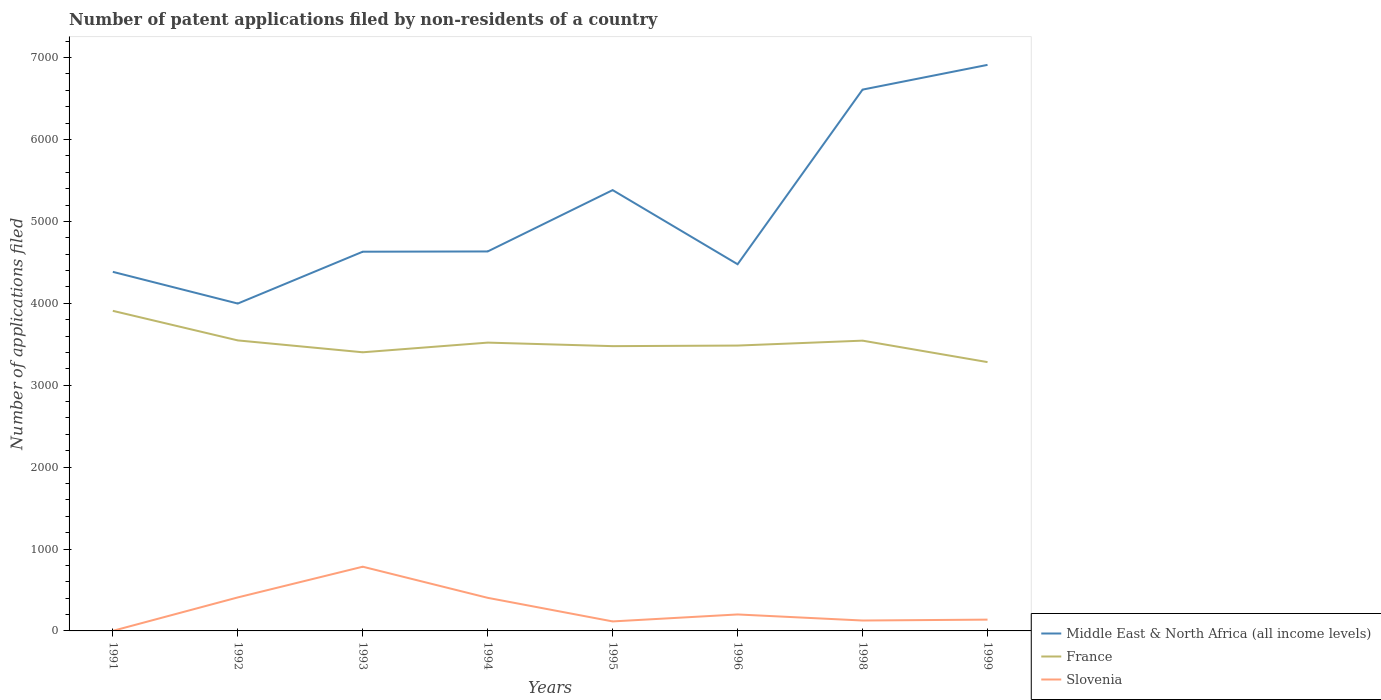Does the line corresponding to Middle East & North Africa (all income levels) intersect with the line corresponding to France?
Give a very brief answer. No. Is the number of lines equal to the number of legend labels?
Give a very brief answer. Yes. Across all years, what is the maximum number of applications filed in Slovenia?
Provide a succinct answer. 1. In which year was the number of applications filed in Slovenia maximum?
Offer a very short reply. 1991. What is the total number of applications filed in Slovenia in the graph?
Offer a terse response. -115. What is the difference between the highest and the second highest number of applications filed in France?
Your answer should be compact. 626. What is the difference between the highest and the lowest number of applications filed in Middle East & North Africa (all income levels)?
Give a very brief answer. 3. What is the difference between two consecutive major ticks on the Y-axis?
Your answer should be compact. 1000. Are the values on the major ticks of Y-axis written in scientific E-notation?
Your response must be concise. No. Does the graph contain any zero values?
Provide a short and direct response. No. Does the graph contain grids?
Provide a short and direct response. No. Where does the legend appear in the graph?
Give a very brief answer. Bottom right. How are the legend labels stacked?
Offer a terse response. Vertical. What is the title of the graph?
Provide a short and direct response. Number of patent applications filed by non-residents of a country. Does "Hungary" appear as one of the legend labels in the graph?
Your answer should be very brief. No. What is the label or title of the X-axis?
Offer a very short reply. Years. What is the label or title of the Y-axis?
Provide a short and direct response. Number of applications filed. What is the Number of applications filed of Middle East & North Africa (all income levels) in 1991?
Offer a very short reply. 4384. What is the Number of applications filed of France in 1991?
Your answer should be very brief. 3908. What is the Number of applications filed in Slovenia in 1991?
Give a very brief answer. 1. What is the Number of applications filed of Middle East & North Africa (all income levels) in 1992?
Offer a very short reply. 3997. What is the Number of applications filed of France in 1992?
Offer a very short reply. 3547. What is the Number of applications filed of Slovenia in 1992?
Ensure brevity in your answer.  409. What is the Number of applications filed in Middle East & North Africa (all income levels) in 1993?
Make the answer very short. 4630. What is the Number of applications filed of France in 1993?
Provide a succinct answer. 3402. What is the Number of applications filed of Slovenia in 1993?
Make the answer very short. 784. What is the Number of applications filed in Middle East & North Africa (all income levels) in 1994?
Provide a succinct answer. 4633. What is the Number of applications filed of France in 1994?
Your answer should be very brief. 3520. What is the Number of applications filed of Slovenia in 1994?
Make the answer very short. 404. What is the Number of applications filed in Middle East & North Africa (all income levels) in 1995?
Your response must be concise. 5382. What is the Number of applications filed in France in 1995?
Keep it short and to the point. 3477. What is the Number of applications filed of Slovenia in 1995?
Your answer should be compact. 116. What is the Number of applications filed in Middle East & North Africa (all income levels) in 1996?
Give a very brief answer. 4477. What is the Number of applications filed in France in 1996?
Your response must be concise. 3484. What is the Number of applications filed of Slovenia in 1996?
Make the answer very short. 201. What is the Number of applications filed of Middle East & North Africa (all income levels) in 1998?
Your answer should be compact. 6609. What is the Number of applications filed of France in 1998?
Give a very brief answer. 3544. What is the Number of applications filed of Slovenia in 1998?
Your answer should be very brief. 127. What is the Number of applications filed in Middle East & North Africa (all income levels) in 1999?
Your answer should be compact. 6911. What is the Number of applications filed in France in 1999?
Ensure brevity in your answer.  3282. What is the Number of applications filed of Slovenia in 1999?
Make the answer very short. 138. Across all years, what is the maximum Number of applications filed in Middle East & North Africa (all income levels)?
Provide a succinct answer. 6911. Across all years, what is the maximum Number of applications filed in France?
Your answer should be compact. 3908. Across all years, what is the maximum Number of applications filed of Slovenia?
Give a very brief answer. 784. Across all years, what is the minimum Number of applications filed in Middle East & North Africa (all income levels)?
Your answer should be compact. 3997. Across all years, what is the minimum Number of applications filed of France?
Offer a terse response. 3282. What is the total Number of applications filed in Middle East & North Africa (all income levels) in the graph?
Your response must be concise. 4.10e+04. What is the total Number of applications filed in France in the graph?
Give a very brief answer. 2.82e+04. What is the total Number of applications filed of Slovenia in the graph?
Provide a short and direct response. 2180. What is the difference between the Number of applications filed of Middle East & North Africa (all income levels) in 1991 and that in 1992?
Provide a succinct answer. 387. What is the difference between the Number of applications filed of France in 1991 and that in 1992?
Your answer should be very brief. 361. What is the difference between the Number of applications filed of Slovenia in 1991 and that in 1992?
Make the answer very short. -408. What is the difference between the Number of applications filed in Middle East & North Africa (all income levels) in 1991 and that in 1993?
Make the answer very short. -246. What is the difference between the Number of applications filed in France in 1991 and that in 1993?
Your response must be concise. 506. What is the difference between the Number of applications filed of Slovenia in 1991 and that in 1993?
Offer a very short reply. -783. What is the difference between the Number of applications filed in Middle East & North Africa (all income levels) in 1991 and that in 1994?
Give a very brief answer. -249. What is the difference between the Number of applications filed in France in 1991 and that in 1994?
Ensure brevity in your answer.  388. What is the difference between the Number of applications filed in Slovenia in 1991 and that in 1994?
Provide a succinct answer. -403. What is the difference between the Number of applications filed in Middle East & North Africa (all income levels) in 1991 and that in 1995?
Provide a succinct answer. -998. What is the difference between the Number of applications filed in France in 1991 and that in 1995?
Your answer should be compact. 431. What is the difference between the Number of applications filed in Slovenia in 1991 and that in 1995?
Offer a terse response. -115. What is the difference between the Number of applications filed of Middle East & North Africa (all income levels) in 1991 and that in 1996?
Your response must be concise. -93. What is the difference between the Number of applications filed of France in 1991 and that in 1996?
Your response must be concise. 424. What is the difference between the Number of applications filed in Slovenia in 1991 and that in 1996?
Keep it short and to the point. -200. What is the difference between the Number of applications filed of Middle East & North Africa (all income levels) in 1991 and that in 1998?
Your answer should be very brief. -2225. What is the difference between the Number of applications filed in France in 1991 and that in 1998?
Make the answer very short. 364. What is the difference between the Number of applications filed in Slovenia in 1991 and that in 1998?
Offer a terse response. -126. What is the difference between the Number of applications filed in Middle East & North Africa (all income levels) in 1991 and that in 1999?
Your answer should be very brief. -2527. What is the difference between the Number of applications filed in France in 1991 and that in 1999?
Make the answer very short. 626. What is the difference between the Number of applications filed in Slovenia in 1991 and that in 1999?
Make the answer very short. -137. What is the difference between the Number of applications filed in Middle East & North Africa (all income levels) in 1992 and that in 1993?
Provide a short and direct response. -633. What is the difference between the Number of applications filed in France in 1992 and that in 1993?
Your answer should be very brief. 145. What is the difference between the Number of applications filed in Slovenia in 1992 and that in 1993?
Offer a terse response. -375. What is the difference between the Number of applications filed in Middle East & North Africa (all income levels) in 1992 and that in 1994?
Make the answer very short. -636. What is the difference between the Number of applications filed in Middle East & North Africa (all income levels) in 1992 and that in 1995?
Keep it short and to the point. -1385. What is the difference between the Number of applications filed of Slovenia in 1992 and that in 1995?
Make the answer very short. 293. What is the difference between the Number of applications filed in Middle East & North Africa (all income levels) in 1992 and that in 1996?
Make the answer very short. -480. What is the difference between the Number of applications filed of Slovenia in 1992 and that in 1996?
Offer a terse response. 208. What is the difference between the Number of applications filed of Middle East & North Africa (all income levels) in 1992 and that in 1998?
Give a very brief answer. -2612. What is the difference between the Number of applications filed of Slovenia in 1992 and that in 1998?
Ensure brevity in your answer.  282. What is the difference between the Number of applications filed in Middle East & North Africa (all income levels) in 1992 and that in 1999?
Your response must be concise. -2914. What is the difference between the Number of applications filed of France in 1992 and that in 1999?
Give a very brief answer. 265. What is the difference between the Number of applications filed of Slovenia in 1992 and that in 1999?
Your response must be concise. 271. What is the difference between the Number of applications filed in Middle East & North Africa (all income levels) in 1993 and that in 1994?
Offer a very short reply. -3. What is the difference between the Number of applications filed in France in 1993 and that in 1994?
Provide a short and direct response. -118. What is the difference between the Number of applications filed of Slovenia in 1993 and that in 1994?
Ensure brevity in your answer.  380. What is the difference between the Number of applications filed in Middle East & North Africa (all income levels) in 1993 and that in 1995?
Keep it short and to the point. -752. What is the difference between the Number of applications filed in France in 1993 and that in 1995?
Provide a succinct answer. -75. What is the difference between the Number of applications filed of Slovenia in 1993 and that in 1995?
Your answer should be compact. 668. What is the difference between the Number of applications filed of Middle East & North Africa (all income levels) in 1993 and that in 1996?
Give a very brief answer. 153. What is the difference between the Number of applications filed in France in 1993 and that in 1996?
Provide a succinct answer. -82. What is the difference between the Number of applications filed of Slovenia in 1993 and that in 1996?
Your response must be concise. 583. What is the difference between the Number of applications filed of Middle East & North Africa (all income levels) in 1993 and that in 1998?
Ensure brevity in your answer.  -1979. What is the difference between the Number of applications filed in France in 1993 and that in 1998?
Your answer should be very brief. -142. What is the difference between the Number of applications filed of Slovenia in 1993 and that in 1998?
Give a very brief answer. 657. What is the difference between the Number of applications filed in Middle East & North Africa (all income levels) in 1993 and that in 1999?
Provide a short and direct response. -2281. What is the difference between the Number of applications filed of France in 1993 and that in 1999?
Provide a succinct answer. 120. What is the difference between the Number of applications filed in Slovenia in 1993 and that in 1999?
Keep it short and to the point. 646. What is the difference between the Number of applications filed of Middle East & North Africa (all income levels) in 1994 and that in 1995?
Ensure brevity in your answer.  -749. What is the difference between the Number of applications filed of France in 1994 and that in 1995?
Make the answer very short. 43. What is the difference between the Number of applications filed of Slovenia in 1994 and that in 1995?
Provide a short and direct response. 288. What is the difference between the Number of applications filed of Middle East & North Africa (all income levels) in 1994 and that in 1996?
Offer a very short reply. 156. What is the difference between the Number of applications filed in Slovenia in 1994 and that in 1996?
Your answer should be very brief. 203. What is the difference between the Number of applications filed in Middle East & North Africa (all income levels) in 1994 and that in 1998?
Offer a terse response. -1976. What is the difference between the Number of applications filed in France in 1994 and that in 1998?
Ensure brevity in your answer.  -24. What is the difference between the Number of applications filed of Slovenia in 1994 and that in 1998?
Your answer should be very brief. 277. What is the difference between the Number of applications filed of Middle East & North Africa (all income levels) in 1994 and that in 1999?
Provide a succinct answer. -2278. What is the difference between the Number of applications filed in France in 1994 and that in 1999?
Make the answer very short. 238. What is the difference between the Number of applications filed in Slovenia in 1994 and that in 1999?
Provide a succinct answer. 266. What is the difference between the Number of applications filed of Middle East & North Africa (all income levels) in 1995 and that in 1996?
Offer a terse response. 905. What is the difference between the Number of applications filed in France in 1995 and that in 1996?
Your response must be concise. -7. What is the difference between the Number of applications filed of Slovenia in 1995 and that in 1996?
Provide a short and direct response. -85. What is the difference between the Number of applications filed in Middle East & North Africa (all income levels) in 1995 and that in 1998?
Offer a terse response. -1227. What is the difference between the Number of applications filed of France in 1995 and that in 1998?
Make the answer very short. -67. What is the difference between the Number of applications filed of Middle East & North Africa (all income levels) in 1995 and that in 1999?
Your response must be concise. -1529. What is the difference between the Number of applications filed in France in 1995 and that in 1999?
Your answer should be compact. 195. What is the difference between the Number of applications filed of Middle East & North Africa (all income levels) in 1996 and that in 1998?
Ensure brevity in your answer.  -2132. What is the difference between the Number of applications filed in France in 1996 and that in 1998?
Provide a short and direct response. -60. What is the difference between the Number of applications filed in Middle East & North Africa (all income levels) in 1996 and that in 1999?
Make the answer very short. -2434. What is the difference between the Number of applications filed of France in 1996 and that in 1999?
Your response must be concise. 202. What is the difference between the Number of applications filed in Middle East & North Africa (all income levels) in 1998 and that in 1999?
Offer a very short reply. -302. What is the difference between the Number of applications filed in France in 1998 and that in 1999?
Make the answer very short. 262. What is the difference between the Number of applications filed in Middle East & North Africa (all income levels) in 1991 and the Number of applications filed in France in 1992?
Your answer should be very brief. 837. What is the difference between the Number of applications filed of Middle East & North Africa (all income levels) in 1991 and the Number of applications filed of Slovenia in 1992?
Offer a terse response. 3975. What is the difference between the Number of applications filed in France in 1991 and the Number of applications filed in Slovenia in 1992?
Keep it short and to the point. 3499. What is the difference between the Number of applications filed in Middle East & North Africa (all income levels) in 1991 and the Number of applications filed in France in 1993?
Offer a very short reply. 982. What is the difference between the Number of applications filed in Middle East & North Africa (all income levels) in 1991 and the Number of applications filed in Slovenia in 1993?
Ensure brevity in your answer.  3600. What is the difference between the Number of applications filed in France in 1991 and the Number of applications filed in Slovenia in 1993?
Your response must be concise. 3124. What is the difference between the Number of applications filed of Middle East & North Africa (all income levels) in 1991 and the Number of applications filed of France in 1994?
Provide a short and direct response. 864. What is the difference between the Number of applications filed of Middle East & North Africa (all income levels) in 1991 and the Number of applications filed of Slovenia in 1994?
Ensure brevity in your answer.  3980. What is the difference between the Number of applications filed of France in 1991 and the Number of applications filed of Slovenia in 1994?
Ensure brevity in your answer.  3504. What is the difference between the Number of applications filed of Middle East & North Africa (all income levels) in 1991 and the Number of applications filed of France in 1995?
Give a very brief answer. 907. What is the difference between the Number of applications filed in Middle East & North Africa (all income levels) in 1991 and the Number of applications filed in Slovenia in 1995?
Your response must be concise. 4268. What is the difference between the Number of applications filed of France in 1991 and the Number of applications filed of Slovenia in 1995?
Ensure brevity in your answer.  3792. What is the difference between the Number of applications filed in Middle East & North Africa (all income levels) in 1991 and the Number of applications filed in France in 1996?
Ensure brevity in your answer.  900. What is the difference between the Number of applications filed in Middle East & North Africa (all income levels) in 1991 and the Number of applications filed in Slovenia in 1996?
Offer a terse response. 4183. What is the difference between the Number of applications filed of France in 1991 and the Number of applications filed of Slovenia in 1996?
Offer a very short reply. 3707. What is the difference between the Number of applications filed in Middle East & North Africa (all income levels) in 1991 and the Number of applications filed in France in 1998?
Make the answer very short. 840. What is the difference between the Number of applications filed in Middle East & North Africa (all income levels) in 1991 and the Number of applications filed in Slovenia in 1998?
Keep it short and to the point. 4257. What is the difference between the Number of applications filed of France in 1991 and the Number of applications filed of Slovenia in 1998?
Offer a very short reply. 3781. What is the difference between the Number of applications filed in Middle East & North Africa (all income levels) in 1991 and the Number of applications filed in France in 1999?
Make the answer very short. 1102. What is the difference between the Number of applications filed in Middle East & North Africa (all income levels) in 1991 and the Number of applications filed in Slovenia in 1999?
Offer a very short reply. 4246. What is the difference between the Number of applications filed of France in 1991 and the Number of applications filed of Slovenia in 1999?
Provide a succinct answer. 3770. What is the difference between the Number of applications filed of Middle East & North Africa (all income levels) in 1992 and the Number of applications filed of France in 1993?
Keep it short and to the point. 595. What is the difference between the Number of applications filed of Middle East & North Africa (all income levels) in 1992 and the Number of applications filed of Slovenia in 1993?
Your answer should be compact. 3213. What is the difference between the Number of applications filed of France in 1992 and the Number of applications filed of Slovenia in 1993?
Provide a short and direct response. 2763. What is the difference between the Number of applications filed in Middle East & North Africa (all income levels) in 1992 and the Number of applications filed in France in 1994?
Your response must be concise. 477. What is the difference between the Number of applications filed in Middle East & North Africa (all income levels) in 1992 and the Number of applications filed in Slovenia in 1994?
Your answer should be very brief. 3593. What is the difference between the Number of applications filed of France in 1992 and the Number of applications filed of Slovenia in 1994?
Offer a very short reply. 3143. What is the difference between the Number of applications filed of Middle East & North Africa (all income levels) in 1992 and the Number of applications filed of France in 1995?
Your answer should be compact. 520. What is the difference between the Number of applications filed of Middle East & North Africa (all income levels) in 1992 and the Number of applications filed of Slovenia in 1995?
Your response must be concise. 3881. What is the difference between the Number of applications filed in France in 1992 and the Number of applications filed in Slovenia in 1995?
Your response must be concise. 3431. What is the difference between the Number of applications filed in Middle East & North Africa (all income levels) in 1992 and the Number of applications filed in France in 1996?
Your answer should be compact. 513. What is the difference between the Number of applications filed in Middle East & North Africa (all income levels) in 1992 and the Number of applications filed in Slovenia in 1996?
Ensure brevity in your answer.  3796. What is the difference between the Number of applications filed in France in 1992 and the Number of applications filed in Slovenia in 1996?
Make the answer very short. 3346. What is the difference between the Number of applications filed of Middle East & North Africa (all income levels) in 1992 and the Number of applications filed of France in 1998?
Keep it short and to the point. 453. What is the difference between the Number of applications filed in Middle East & North Africa (all income levels) in 1992 and the Number of applications filed in Slovenia in 1998?
Offer a very short reply. 3870. What is the difference between the Number of applications filed of France in 1992 and the Number of applications filed of Slovenia in 1998?
Keep it short and to the point. 3420. What is the difference between the Number of applications filed of Middle East & North Africa (all income levels) in 1992 and the Number of applications filed of France in 1999?
Offer a terse response. 715. What is the difference between the Number of applications filed in Middle East & North Africa (all income levels) in 1992 and the Number of applications filed in Slovenia in 1999?
Provide a succinct answer. 3859. What is the difference between the Number of applications filed of France in 1992 and the Number of applications filed of Slovenia in 1999?
Provide a short and direct response. 3409. What is the difference between the Number of applications filed in Middle East & North Africa (all income levels) in 1993 and the Number of applications filed in France in 1994?
Make the answer very short. 1110. What is the difference between the Number of applications filed in Middle East & North Africa (all income levels) in 1993 and the Number of applications filed in Slovenia in 1994?
Offer a terse response. 4226. What is the difference between the Number of applications filed in France in 1993 and the Number of applications filed in Slovenia in 1994?
Keep it short and to the point. 2998. What is the difference between the Number of applications filed in Middle East & North Africa (all income levels) in 1993 and the Number of applications filed in France in 1995?
Ensure brevity in your answer.  1153. What is the difference between the Number of applications filed in Middle East & North Africa (all income levels) in 1993 and the Number of applications filed in Slovenia in 1995?
Keep it short and to the point. 4514. What is the difference between the Number of applications filed of France in 1993 and the Number of applications filed of Slovenia in 1995?
Make the answer very short. 3286. What is the difference between the Number of applications filed of Middle East & North Africa (all income levels) in 1993 and the Number of applications filed of France in 1996?
Your response must be concise. 1146. What is the difference between the Number of applications filed in Middle East & North Africa (all income levels) in 1993 and the Number of applications filed in Slovenia in 1996?
Offer a very short reply. 4429. What is the difference between the Number of applications filed in France in 1993 and the Number of applications filed in Slovenia in 1996?
Your answer should be compact. 3201. What is the difference between the Number of applications filed in Middle East & North Africa (all income levels) in 1993 and the Number of applications filed in France in 1998?
Ensure brevity in your answer.  1086. What is the difference between the Number of applications filed in Middle East & North Africa (all income levels) in 1993 and the Number of applications filed in Slovenia in 1998?
Provide a succinct answer. 4503. What is the difference between the Number of applications filed in France in 1993 and the Number of applications filed in Slovenia in 1998?
Keep it short and to the point. 3275. What is the difference between the Number of applications filed in Middle East & North Africa (all income levels) in 1993 and the Number of applications filed in France in 1999?
Provide a succinct answer. 1348. What is the difference between the Number of applications filed in Middle East & North Africa (all income levels) in 1993 and the Number of applications filed in Slovenia in 1999?
Provide a succinct answer. 4492. What is the difference between the Number of applications filed of France in 1993 and the Number of applications filed of Slovenia in 1999?
Provide a succinct answer. 3264. What is the difference between the Number of applications filed in Middle East & North Africa (all income levels) in 1994 and the Number of applications filed in France in 1995?
Offer a very short reply. 1156. What is the difference between the Number of applications filed of Middle East & North Africa (all income levels) in 1994 and the Number of applications filed of Slovenia in 1995?
Offer a terse response. 4517. What is the difference between the Number of applications filed of France in 1994 and the Number of applications filed of Slovenia in 1995?
Provide a short and direct response. 3404. What is the difference between the Number of applications filed of Middle East & North Africa (all income levels) in 1994 and the Number of applications filed of France in 1996?
Make the answer very short. 1149. What is the difference between the Number of applications filed in Middle East & North Africa (all income levels) in 1994 and the Number of applications filed in Slovenia in 1996?
Offer a very short reply. 4432. What is the difference between the Number of applications filed in France in 1994 and the Number of applications filed in Slovenia in 1996?
Your response must be concise. 3319. What is the difference between the Number of applications filed of Middle East & North Africa (all income levels) in 1994 and the Number of applications filed of France in 1998?
Offer a very short reply. 1089. What is the difference between the Number of applications filed of Middle East & North Africa (all income levels) in 1994 and the Number of applications filed of Slovenia in 1998?
Keep it short and to the point. 4506. What is the difference between the Number of applications filed of France in 1994 and the Number of applications filed of Slovenia in 1998?
Ensure brevity in your answer.  3393. What is the difference between the Number of applications filed in Middle East & North Africa (all income levels) in 1994 and the Number of applications filed in France in 1999?
Your answer should be compact. 1351. What is the difference between the Number of applications filed of Middle East & North Africa (all income levels) in 1994 and the Number of applications filed of Slovenia in 1999?
Offer a terse response. 4495. What is the difference between the Number of applications filed of France in 1994 and the Number of applications filed of Slovenia in 1999?
Provide a short and direct response. 3382. What is the difference between the Number of applications filed in Middle East & North Africa (all income levels) in 1995 and the Number of applications filed in France in 1996?
Your response must be concise. 1898. What is the difference between the Number of applications filed of Middle East & North Africa (all income levels) in 1995 and the Number of applications filed of Slovenia in 1996?
Your answer should be compact. 5181. What is the difference between the Number of applications filed in France in 1995 and the Number of applications filed in Slovenia in 1996?
Keep it short and to the point. 3276. What is the difference between the Number of applications filed of Middle East & North Africa (all income levels) in 1995 and the Number of applications filed of France in 1998?
Your response must be concise. 1838. What is the difference between the Number of applications filed of Middle East & North Africa (all income levels) in 1995 and the Number of applications filed of Slovenia in 1998?
Offer a terse response. 5255. What is the difference between the Number of applications filed of France in 1995 and the Number of applications filed of Slovenia in 1998?
Provide a succinct answer. 3350. What is the difference between the Number of applications filed in Middle East & North Africa (all income levels) in 1995 and the Number of applications filed in France in 1999?
Keep it short and to the point. 2100. What is the difference between the Number of applications filed of Middle East & North Africa (all income levels) in 1995 and the Number of applications filed of Slovenia in 1999?
Offer a very short reply. 5244. What is the difference between the Number of applications filed in France in 1995 and the Number of applications filed in Slovenia in 1999?
Your answer should be very brief. 3339. What is the difference between the Number of applications filed of Middle East & North Africa (all income levels) in 1996 and the Number of applications filed of France in 1998?
Your response must be concise. 933. What is the difference between the Number of applications filed of Middle East & North Africa (all income levels) in 1996 and the Number of applications filed of Slovenia in 1998?
Give a very brief answer. 4350. What is the difference between the Number of applications filed in France in 1996 and the Number of applications filed in Slovenia in 1998?
Offer a very short reply. 3357. What is the difference between the Number of applications filed of Middle East & North Africa (all income levels) in 1996 and the Number of applications filed of France in 1999?
Your answer should be very brief. 1195. What is the difference between the Number of applications filed of Middle East & North Africa (all income levels) in 1996 and the Number of applications filed of Slovenia in 1999?
Provide a succinct answer. 4339. What is the difference between the Number of applications filed in France in 1996 and the Number of applications filed in Slovenia in 1999?
Ensure brevity in your answer.  3346. What is the difference between the Number of applications filed of Middle East & North Africa (all income levels) in 1998 and the Number of applications filed of France in 1999?
Your answer should be very brief. 3327. What is the difference between the Number of applications filed of Middle East & North Africa (all income levels) in 1998 and the Number of applications filed of Slovenia in 1999?
Make the answer very short. 6471. What is the difference between the Number of applications filed in France in 1998 and the Number of applications filed in Slovenia in 1999?
Provide a short and direct response. 3406. What is the average Number of applications filed of Middle East & North Africa (all income levels) per year?
Your answer should be compact. 5127.88. What is the average Number of applications filed in France per year?
Give a very brief answer. 3520.5. What is the average Number of applications filed of Slovenia per year?
Your response must be concise. 272.5. In the year 1991, what is the difference between the Number of applications filed of Middle East & North Africa (all income levels) and Number of applications filed of France?
Keep it short and to the point. 476. In the year 1991, what is the difference between the Number of applications filed in Middle East & North Africa (all income levels) and Number of applications filed in Slovenia?
Provide a succinct answer. 4383. In the year 1991, what is the difference between the Number of applications filed in France and Number of applications filed in Slovenia?
Your answer should be compact. 3907. In the year 1992, what is the difference between the Number of applications filed of Middle East & North Africa (all income levels) and Number of applications filed of France?
Provide a short and direct response. 450. In the year 1992, what is the difference between the Number of applications filed of Middle East & North Africa (all income levels) and Number of applications filed of Slovenia?
Your response must be concise. 3588. In the year 1992, what is the difference between the Number of applications filed of France and Number of applications filed of Slovenia?
Offer a very short reply. 3138. In the year 1993, what is the difference between the Number of applications filed of Middle East & North Africa (all income levels) and Number of applications filed of France?
Provide a short and direct response. 1228. In the year 1993, what is the difference between the Number of applications filed in Middle East & North Africa (all income levels) and Number of applications filed in Slovenia?
Your answer should be compact. 3846. In the year 1993, what is the difference between the Number of applications filed of France and Number of applications filed of Slovenia?
Offer a very short reply. 2618. In the year 1994, what is the difference between the Number of applications filed of Middle East & North Africa (all income levels) and Number of applications filed of France?
Provide a succinct answer. 1113. In the year 1994, what is the difference between the Number of applications filed of Middle East & North Africa (all income levels) and Number of applications filed of Slovenia?
Offer a very short reply. 4229. In the year 1994, what is the difference between the Number of applications filed in France and Number of applications filed in Slovenia?
Keep it short and to the point. 3116. In the year 1995, what is the difference between the Number of applications filed of Middle East & North Africa (all income levels) and Number of applications filed of France?
Offer a very short reply. 1905. In the year 1995, what is the difference between the Number of applications filed in Middle East & North Africa (all income levels) and Number of applications filed in Slovenia?
Provide a short and direct response. 5266. In the year 1995, what is the difference between the Number of applications filed in France and Number of applications filed in Slovenia?
Provide a short and direct response. 3361. In the year 1996, what is the difference between the Number of applications filed of Middle East & North Africa (all income levels) and Number of applications filed of France?
Your answer should be compact. 993. In the year 1996, what is the difference between the Number of applications filed in Middle East & North Africa (all income levels) and Number of applications filed in Slovenia?
Your response must be concise. 4276. In the year 1996, what is the difference between the Number of applications filed in France and Number of applications filed in Slovenia?
Offer a terse response. 3283. In the year 1998, what is the difference between the Number of applications filed of Middle East & North Africa (all income levels) and Number of applications filed of France?
Give a very brief answer. 3065. In the year 1998, what is the difference between the Number of applications filed of Middle East & North Africa (all income levels) and Number of applications filed of Slovenia?
Keep it short and to the point. 6482. In the year 1998, what is the difference between the Number of applications filed of France and Number of applications filed of Slovenia?
Your answer should be very brief. 3417. In the year 1999, what is the difference between the Number of applications filed of Middle East & North Africa (all income levels) and Number of applications filed of France?
Give a very brief answer. 3629. In the year 1999, what is the difference between the Number of applications filed in Middle East & North Africa (all income levels) and Number of applications filed in Slovenia?
Provide a succinct answer. 6773. In the year 1999, what is the difference between the Number of applications filed of France and Number of applications filed of Slovenia?
Ensure brevity in your answer.  3144. What is the ratio of the Number of applications filed in Middle East & North Africa (all income levels) in 1991 to that in 1992?
Offer a terse response. 1.1. What is the ratio of the Number of applications filed in France in 1991 to that in 1992?
Your answer should be very brief. 1.1. What is the ratio of the Number of applications filed of Slovenia in 1991 to that in 1992?
Offer a terse response. 0. What is the ratio of the Number of applications filed of Middle East & North Africa (all income levels) in 1991 to that in 1993?
Offer a terse response. 0.95. What is the ratio of the Number of applications filed of France in 1991 to that in 1993?
Your answer should be compact. 1.15. What is the ratio of the Number of applications filed of Slovenia in 1991 to that in 1993?
Offer a very short reply. 0. What is the ratio of the Number of applications filed of Middle East & North Africa (all income levels) in 1991 to that in 1994?
Ensure brevity in your answer.  0.95. What is the ratio of the Number of applications filed in France in 1991 to that in 1994?
Ensure brevity in your answer.  1.11. What is the ratio of the Number of applications filed in Slovenia in 1991 to that in 1994?
Ensure brevity in your answer.  0. What is the ratio of the Number of applications filed in Middle East & North Africa (all income levels) in 1991 to that in 1995?
Ensure brevity in your answer.  0.81. What is the ratio of the Number of applications filed in France in 1991 to that in 1995?
Make the answer very short. 1.12. What is the ratio of the Number of applications filed in Slovenia in 1991 to that in 1995?
Keep it short and to the point. 0.01. What is the ratio of the Number of applications filed of Middle East & North Africa (all income levels) in 1991 to that in 1996?
Keep it short and to the point. 0.98. What is the ratio of the Number of applications filed of France in 1991 to that in 1996?
Provide a succinct answer. 1.12. What is the ratio of the Number of applications filed of Slovenia in 1991 to that in 1996?
Provide a short and direct response. 0.01. What is the ratio of the Number of applications filed in Middle East & North Africa (all income levels) in 1991 to that in 1998?
Give a very brief answer. 0.66. What is the ratio of the Number of applications filed in France in 1991 to that in 1998?
Make the answer very short. 1.1. What is the ratio of the Number of applications filed of Slovenia in 1991 to that in 1998?
Give a very brief answer. 0.01. What is the ratio of the Number of applications filed in Middle East & North Africa (all income levels) in 1991 to that in 1999?
Your answer should be very brief. 0.63. What is the ratio of the Number of applications filed in France in 1991 to that in 1999?
Offer a very short reply. 1.19. What is the ratio of the Number of applications filed in Slovenia in 1991 to that in 1999?
Ensure brevity in your answer.  0.01. What is the ratio of the Number of applications filed of Middle East & North Africa (all income levels) in 1992 to that in 1993?
Provide a short and direct response. 0.86. What is the ratio of the Number of applications filed of France in 1992 to that in 1993?
Offer a terse response. 1.04. What is the ratio of the Number of applications filed of Slovenia in 1992 to that in 1993?
Ensure brevity in your answer.  0.52. What is the ratio of the Number of applications filed of Middle East & North Africa (all income levels) in 1992 to that in 1994?
Ensure brevity in your answer.  0.86. What is the ratio of the Number of applications filed of France in 1992 to that in 1994?
Your response must be concise. 1.01. What is the ratio of the Number of applications filed in Slovenia in 1992 to that in 1994?
Provide a succinct answer. 1.01. What is the ratio of the Number of applications filed in Middle East & North Africa (all income levels) in 1992 to that in 1995?
Provide a succinct answer. 0.74. What is the ratio of the Number of applications filed in France in 1992 to that in 1995?
Your answer should be very brief. 1.02. What is the ratio of the Number of applications filed in Slovenia in 1992 to that in 1995?
Your answer should be compact. 3.53. What is the ratio of the Number of applications filed of Middle East & North Africa (all income levels) in 1992 to that in 1996?
Ensure brevity in your answer.  0.89. What is the ratio of the Number of applications filed in France in 1992 to that in 1996?
Your answer should be compact. 1.02. What is the ratio of the Number of applications filed in Slovenia in 1992 to that in 1996?
Keep it short and to the point. 2.03. What is the ratio of the Number of applications filed in Middle East & North Africa (all income levels) in 1992 to that in 1998?
Give a very brief answer. 0.6. What is the ratio of the Number of applications filed in France in 1992 to that in 1998?
Offer a very short reply. 1. What is the ratio of the Number of applications filed in Slovenia in 1992 to that in 1998?
Keep it short and to the point. 3.22. What is the ratio of the Number of applications filed of Middle East & North Africa (all income levels) in 1992 to that in 1999?
Give a very brief answer. 0.58. What is the ratio of the Number of applications filed in France in 1992 to that in 1999?
Provide a short and direct response. 1.08. What is the ratio of the Number of applications filed in Slovenia in 1992 to that in 1999?
Give a very brief answer. 2.96. What is the ratio of the Number of applications filed of France in 1993 to that in 1994?
Offer a very short reply. 0.97. What is the ratio of the Number of applications filed of Slovenia in 1993 to that in 1994?
Your response must be concise. 1.94. What is the ratio of the Number of applications filed in Middle East & North Africa (all income levels) in 1993 to that in 1995?
Provide a succinct answer. 0.86. What is the ratio of the Number of applications filed in France in 1993 to that in 1995?
Your answer should be compact. 0.98. What is the ratio of the Number of applications filed of Slovenia in 1993 to that in 1995?
Provide a succinct answer. 6.76. What is the ratio of the Number of applications filed of Middle East & North Africa (all income levels) in 1993 to that in 1996?
Keep it short and to the point. 1.03. What is the ratio of the Number of applications filed in France in 1993 to that in 1996?
Your response must be concise. 0.98. What is the ratio of the Number of applications filed in Slovenia in 1993 to that in 1996?
Keep it short and to the point. 3.9. What is the ratio of the Number of applications filed in Middle East & North Africa (all income levels) in 1993 to that in 1998?
Ensure brevity in your answer.  0.7. What is the ratio of the Number of applications filed in France in 1993 to that in 1998?
Your answer should be very brief. 0.96. What is the ratio of the Number of applications filed of Slovenia in 1993 to that in 1998?
Your answer should be compact. 6.17. What is the ratio of the Number of applications filed of Middle East & North Africa (all income levels) in 1993 to that in 1999?
Offer a terse response. 0.67. What is the ratio of the Number of applications filed in France in 1993 to that in 1999?
Give a very brief answer. 1.04. What is the ratio of the Number of applications filed in Slovenia in 1993 to that in 1999?
Provide a short and direct response. 5.68. What is the ratio of the Number of applications filed in Middle East & North Africa (all income levels) in 1994 to that in 1995?
Offer a terse response. 0.86. What is the ratio of the Number of applications filed in France in 1994 to that in 1995?
Offer a terse response. 1.01. What is the ratio of the Number of applications filed of Slovenia in 1994 to that in 1995?
Offer a very short reply. 3.48. What is the ratio of the Number of applications filed of Middle East & North Africa (all income levels) in 1994 to that in 1996?
Ensure brevity in your answer.  1.03. What is the ratio of the Number of applications filed in France in 1994 to that in 1996?
Make the answer very short. 1.01. What is the ratio of the Number of applications filed of Slovenia in 1994 to that in 1996?
Ensure brevity in your answer.  2.01. What is the ratio of the Number of applications filed of Middle East & North Africa (all income levels) in 1994 to that in 1998?
Your response must be concise. 0.7. What is the ratio of the Number of applications filed in France in 1994 to that in 1998?
Provide a short and direct response. 0.99. What is the ratio of the Number of applications filed of Slovenia in 1994 to that in 1998?
Your answer should be compact. 3.18. What is the ratio of the Number of applications filed of Middle East & North Africa (all income levels) in 1994 to that in 1999?
Your answer should be very brief. 0.67. What is the ratio of the Number of applications filed of France in 1994 to that in 1999?
Offer a very short reply. 1.07. What is the ratio of the Number of applications filed of Slovenia in 1994 to that in 1999?
Give a very brief answer. 2.93. What is the ratio of the Number of applications filed of Middle East & North Africa (all income levels) in 1995 to that in 1996?
Provide a succinct answer. 1.2. What is the ratio of the Number of applications filed of France in 1995 to that in 1996?
Your response must be concise. 1. What is the ratio of the Number of applications filed of Slovenia in 1995 to that in 1996?
Your answer should be very brief. 0.58. What is the ratio of the Number of applications filed of Middle East & North Africa (all income levels) in 1995 to that in 1998?
Ensure brevity in your answer.  0.81. What is the ratio of the Number of applications filed of France in 1995 to that in 1998?
Make the answer very short. 0.98. What is the ratio of the Number of applications filed in Slovenia in 1995 to that in 1998?
Provide a succinct answer. 0.91. What is the ratio of the Number of applications filed in Middle East & North Africa (all income levels) in 1995 to that in 1999?
Your answer should be compact. 0.78. What is the ratio of the Number of applications filed in France in 1995 to that in 1999?
Keep it short and to the point. 1.06. What is the ratio of the Number of applications filed in Slovenia in 1995 to that in 1999?
Make the answer very short. 0.84. What is the ratio of the Number of applications filed of Middle East & North Africa (all income levels) in 1996 to that in 1998?
Offer a very short reply. 0.68. What is the ratio of the Number of applications filed of France in 1996 to that in 1998?
Ensure brevity in your answer.  0.98. What is the ratio of the Number of applications filed in Slovenia in 1996 to that in 1998?
Offer a very short reply. 1.58. What is the ratio of the Number of applications filed in Middle East & North Africa (all income levels) in 1996 to that in 1999?
Give a very brief answer. 0.65. What is the ratio of the Number of applications filed of France in 1996 to that in 1999?
Provide a short and direct response. 1.06. What is the ratio of the Number of applications filed in Slovenia in 1996 to that in 1999?
Ensure brevity in your answer.  1.46. What is the ratio of the Number of applications filed in Middle East & North Africa (all income levels) in 1998 to that in 1999?
Give a very brief answer. 0.96. What is the ratio of the Number of applications filed of France in 1998 to that in 1999?
Your response must be concise. 1.08. What is the ratio of the Number of applications filed of Slovenia in 1998 to that in 1999?
Give a very brief answer. 0.92. What is the difference between the highest and the second highest Number of applications filed in Middle East & North Africa (all income levels)?
Your answer should be very brief. 302. What is the difference between the highest and the second highest Number of applications filed of France?
Your answer should be very brief. 361. What is the difference between the highest and the second highest Number of applications filed of Slovenia?
Give a very brief answer. 375. What is the difference between the highest and the lowest Number of applications filed of Middle East & North Africa (all income levels)?
Make the answer very short. 2914. What is the difference between the highest and the lowest Number of applications filed of France?
Your response must be concise. 626. What is the difference between the highest and the lowest Number of applications filed in Slovenia?
Keep it short and to the point. 783. 